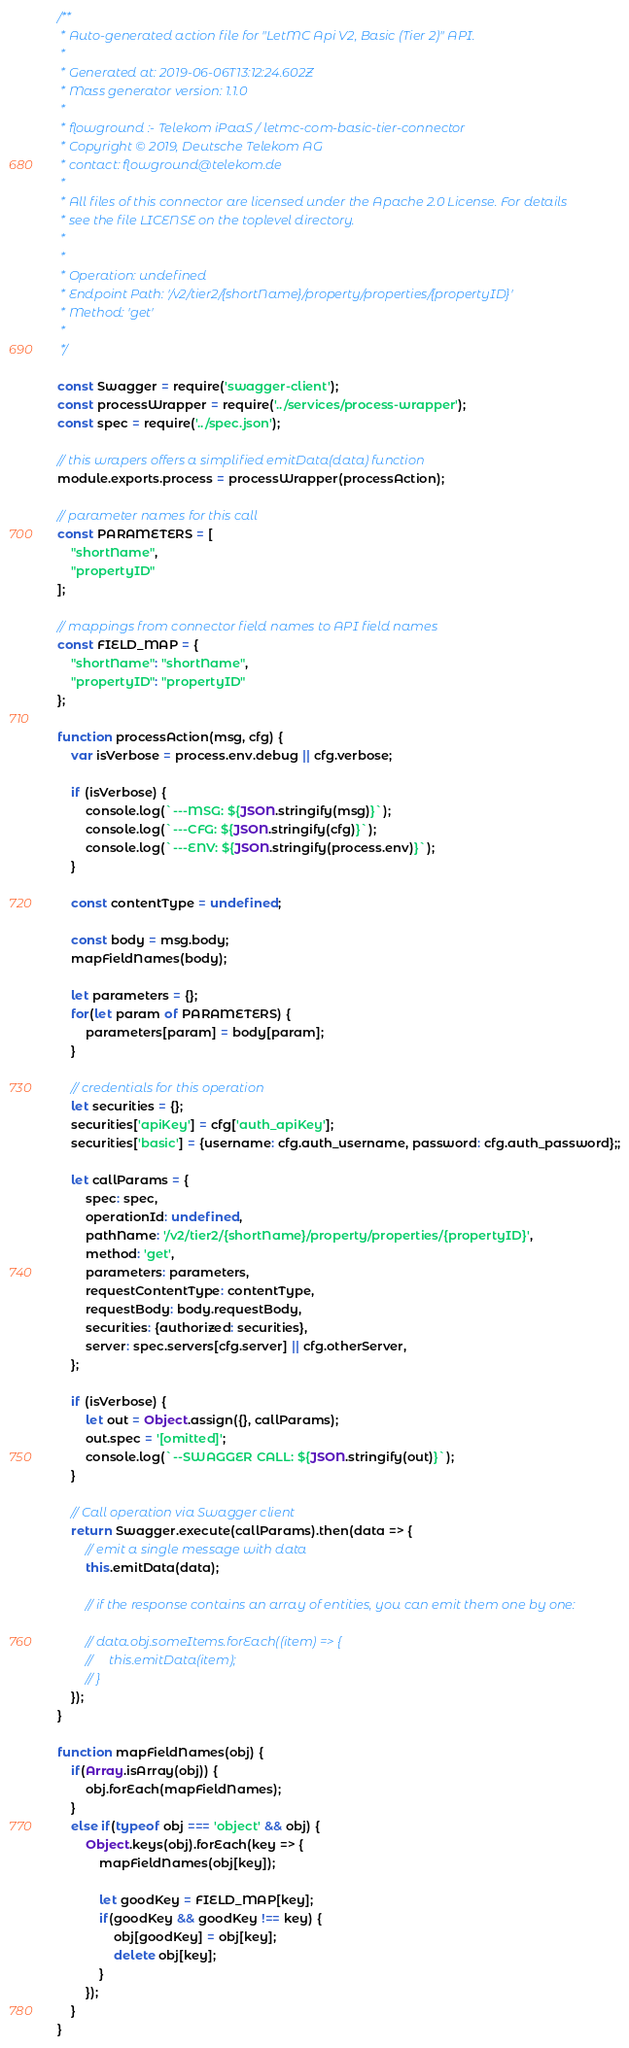Convert code to text. <code><loc_0><loc_0><loc_500><loc_500><_JavaScript_>/**
 * Auto-generated action file for "LetMC Api V2, Basic (Tier 2)" API.
 *
 * Generated at: 2019-06-06T13:12:24.602Z
 * Mass generator version: 1.1.0
 *
 * flowground :- Telekom iPaaS / letmc-com-basic-tier-connector
 * Copyright © 2019, Deutsche Telekom AG
 * contact: flowground@telekom.de
 *
 * All files of this connector are licensed under the Apache 2.0 License. For details
 * see the file LICENSE on the toplevel directory.
 *
 *
 * Operation: undefined
 * Endpoint Path: '/v2/tier2/{shortName}/property/properties/{propertyID}'
 * Method: 'get'
 *
 */

const Swagger = require('swagger-client');
const processWrapper = require('../services/process-wrapper');
const spec = require('../spec.json');

// this wrapers offers a simplified emitData(data) function
module.exports.process = processWrapper(processAction);

// parameter names for this call
const PARAMETERS = [
    "shortName",
    "propertyID"
];

// mappings from connector field names to API field names
const FIELD_MAP = {
    "shortName": "shortName",
    "propertyID": "propertyID"
};

function processAction(msg, cfg) {
    var isVerbose = process.env.debug || cfg.verbose;

    if (isVerbose) {
        console.log(`---MSG: ${JSON.stringify(msg)}`);
        console.log(`---CFG: ${JSON.stringify(cfg)}`);
        console.log(`---ENV: ${JSON.stringify(process.env)}`);
    }

    const contentType = undefined;

    const body = msg.body;
    mapFieldNames(body);

    let parameters = {};
    for(let param of PARAMETERS) {
        parameters[param] = body[param];
    }

    // credentials for this operation
    let securities = {};
    securities['apiKey'] = cfg['auth_apiKey'];
    securities['basic'] = {username: cfg.auth_username, password: cfg.auth_password};;

    let callParams = {
        spec: spec,
        operationId: undefined,
        pathName: '/v2/tier2/{shortName}/property/properties/{propertyID}',
        method: 'get',
        parameters: parameters,
        requestContentType: contentType,
        requestBody: body.requestBody,
        securities: {authorized: securities},
        server: spec.servers[cfg.server] || cfg.otherServer,
    };

    if (isVerbose) {
        let out = Object.assign({}, callParams);
        out.spec = '[omitted]';
        console.log(`--SWAGGER CALL: ${JSON.stringify(out)}`);
    }

    // Call operation via Swagger client
    return Swagger.execute(callParams).then(data => {
        // emit a single message with data
        this.emitData(data);

        // if the response contains an array of entities, you can emit them one by one:

        // data.obj.someItems.forEach((item) => {
        //     this.emitData(item);
        // }
    });
}

function mapFieldNames(obj) {
    if(Array.isArray(obj)) {
        obj.forEach(mapFieldNames);
    }
    else if(typeof obj === 'object' && obj) {
        Object.keys(obj).forEach(key => {
            mapFieldNames(obj[key]);

            let goodKey = FIELD_MAP[key];
            if(goodKey && goodKey !== key) {
                obj[goodKey] = obj[key];
                delete obj[key];
            }
        });
    }
}</code> 